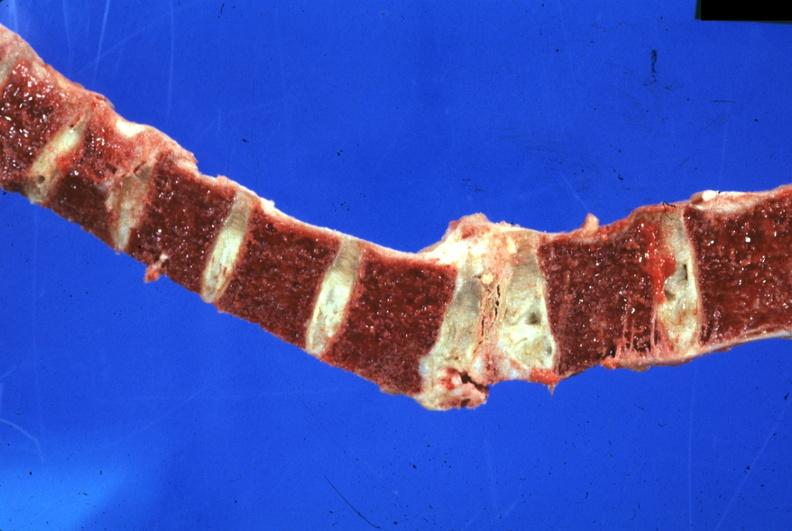does this image show old lesion well shown?
Answer the question using a single word or phrase. Yes 